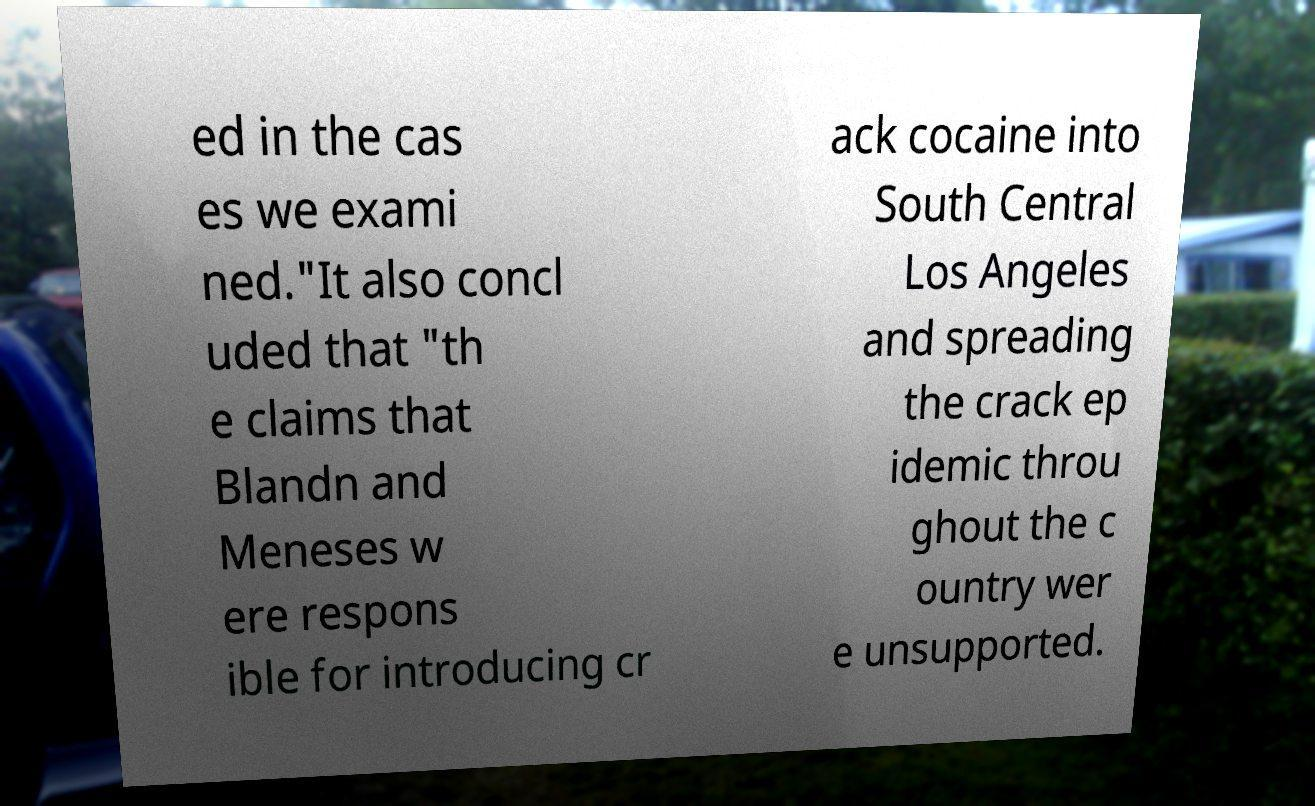Please identify and transcribe the text found in this image. ed in the cas es we exami ned."It also concl uded that "th e claims that Blandn and Meneses w ere respons ible for introducing cr ack cocaine into South Central Los Angeles and spreading the crack ep idemic throu ghout the c ountry wer e unsupported. 